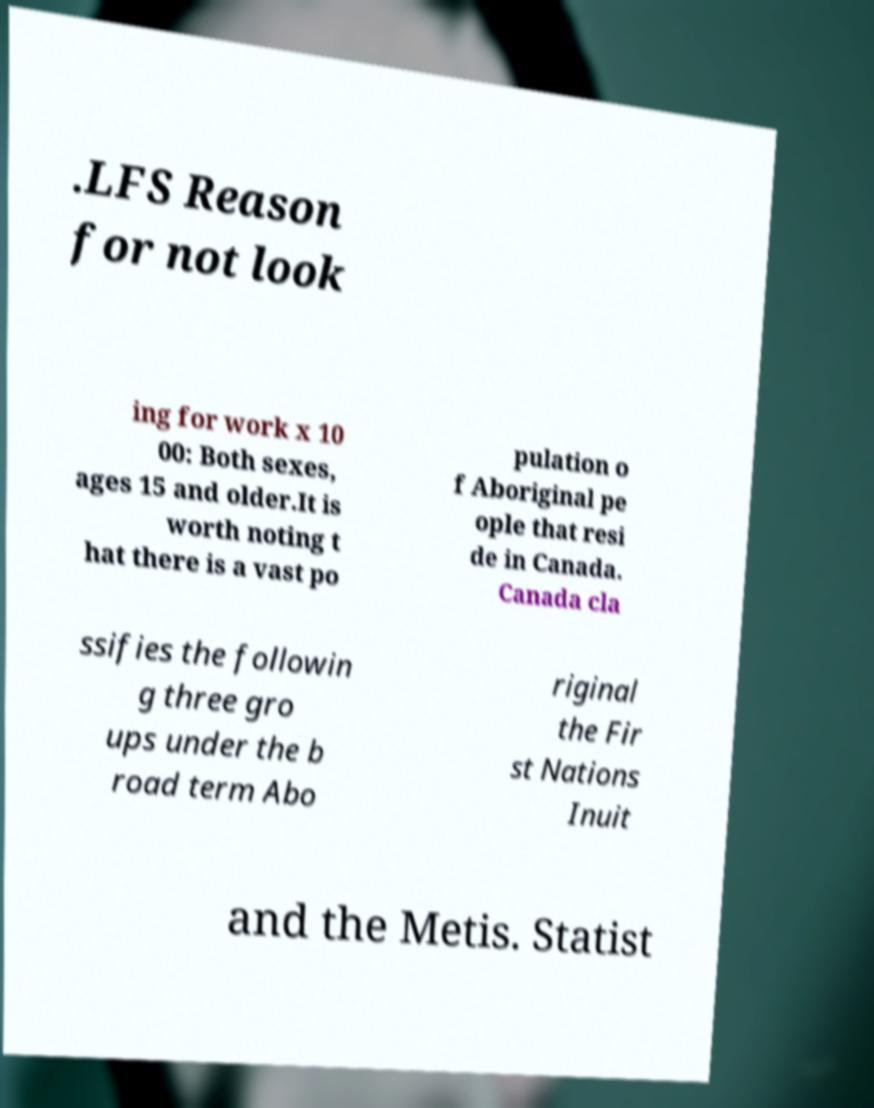Please read and relay the text visible in this image. What does it say? .LFS Reason for not look ing for work x 10 00: Both sexes, ages 15 and older.It is worth noting t hat there is a vast po pulation o f Aboriginal pe ople that resi de in Canada. Canada cla ssifies the followin g three gro ups under the b road term Abo riginal the Fir st Nations Inuit and the Metis. Statist 